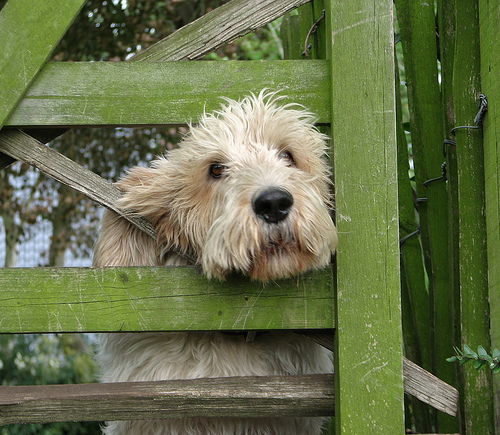<image>
Is the dog in the gate? Yes. The dog is contained within or inside the gate, showing a containment relationship. 